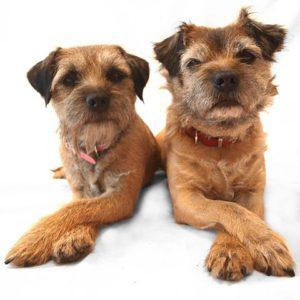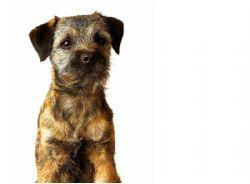The first image is the image on the left, the second image is the image on the right. Examine the images to the left and right. Is the description "The combined images contain three dogs, and one image contains a pair of similarly-posed reclining dogs." accurate? Answer yes or no. Yes. The first image is the image on the left, the second image is the image on the right. Examine the images to the left and right. Is the description "In one image two dogs are laying down." accurate? Answer yes or no. Yes. 